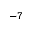Convert formula to latex. <formula><loc_0><loc_0><loc_500><loc_500>^ { - 7 }</formula> 